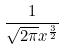<formula> <loc_0><loc_0><loc_500><loc_500>\frac { 1 } { \sqrt { 2 \pi } x ^ { \frac { 3 } { 2 } } }</formula> 